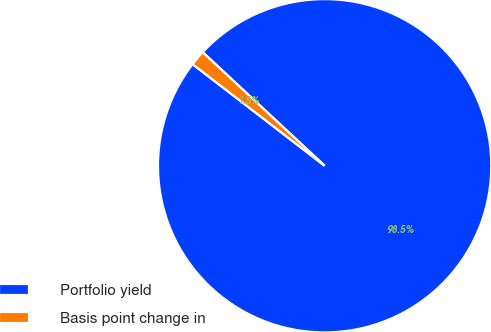Convert chart to OTSL. <chart><loc_0><loc_0><loc_500><loc_500><pie_chart><fcel>Portfolio yield<fcel>Basis point change in<nl><fcel>98.51%<fcel>1.49%<nl></chart> 